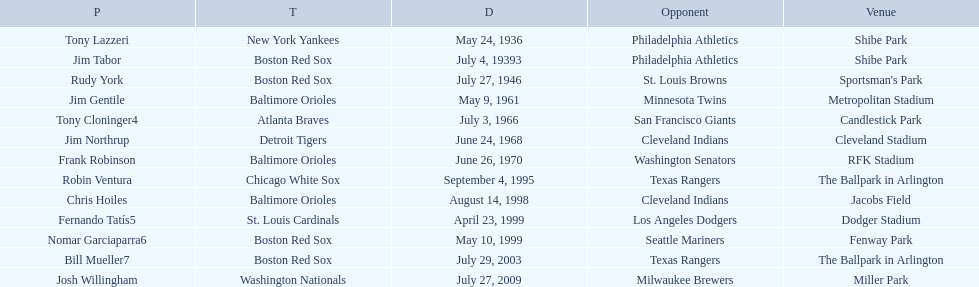What were the dates of each game? May 24, 1936, July 4, 19393, July 27, 1946, May 9, 1961, July 3, 1966, June 24, 1968, June 26, 1970, September 4, 1995, August 14, 1998, April 23, 1999, May 10, 1999, July 29, 2003, July 27, 2009. Who were all of the teams? New York Yankees, Boston Red Sox, Boston Red Sox, Baltimore Orioles, Atlanta Braves, Detroit Tigers, Baltimore Orioles, Chicago White Sox, Baltimore Orioles, St. Louis Cardinals, Boston Red Sox, Boston Red Sox, Washington Nationals. What about their opponents? Philadelphia Athletics, Philadelphia Athletics, St. Louis Browns, Minnesota Twins, San Francisco Giants, Cleveland Indians, Washington Senators, Texas Rangers, Cleveland Indians, Los Angeles Dodgers, Seattle Mariners, Texas Rangers, Milwaukee Brewers. And on which date did the detroit tigers play against the cleveland indians? June 24, 1968. 